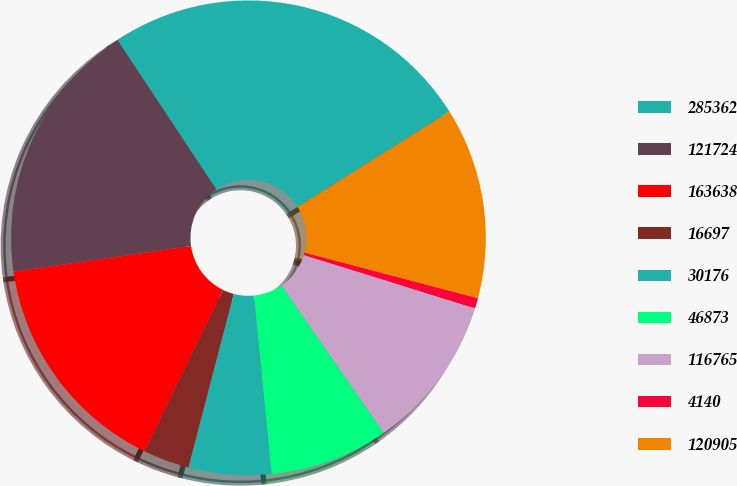Convert chart to OTSL. <chart><loc_0><loc_0><loc_500><loc_500><pie_chart><fcel>285362<fcel>121724<fcel>163638<fcel>16697<fcel>30176<fcel>46873<fcel>116765<fcel>4140<fcel>120905<nl><fcel>25.38%<fcel>17.97%<fcel>15.5%<fcel>3.16%<fcel>5.62%<fcel>8.09%<fcel>10.56%<fcel>0.69%<fcel>13.03%<nl></chart> 